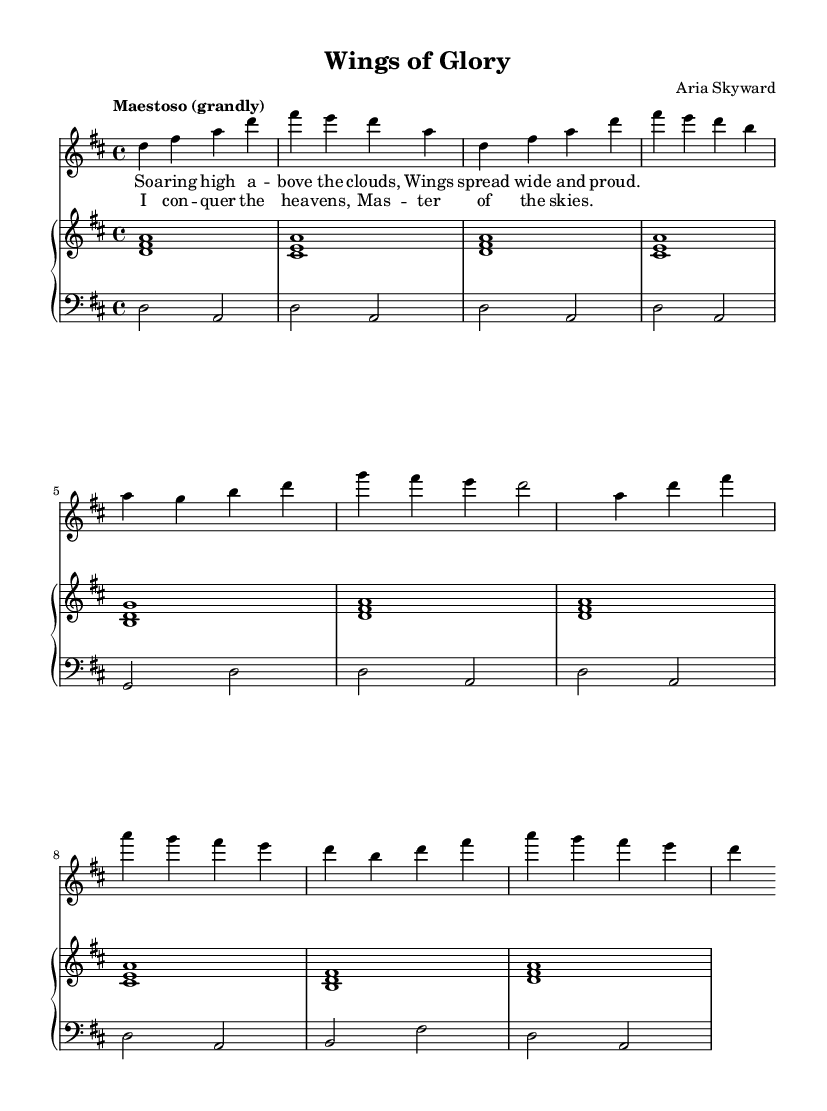What is the key signature of this music? The key signature is indicated at the beginning of the staff and shows two sharps, which corresponds to D major.
Answer: D major What is the time signature of this opera piece? The time signature is displayed next to the key signature at the beginning, indicating how many beats are in each measure. In this case, it shows 4 beats per measure.
Answer: 4/4 What is the tempo marking for this piece? The tempo marking is written above the music and indicates the speed of the piece. Here it is described as "Maestoso," which means it should be played grandly and stately.
Answer: Maestoso How many measures are there in the chorus section? By counting the measures within the chorus part of the sheet music, we can find that it contains four measures.
Answer: 4 Which voice part has the highest pitch range? By looking at the provided vocal lines, the soprano part, indicated at the top of the score, typically has the highest pitch range compared to the bass and piano parts.
Answer: Soprano What is the main theme expressed in the lyrics? The lyrics express themes of soaring above the clouds and conquering the heavens, indicating a connection to triumph and freedom in the sky.
Answer: Soaring high above the clouds How does the piano accompaniment contribute to the overall piece? The piano accompaniment provides harmonic support and emphasizes the structure of the opera, playing chords that complement the soprano's melodic line while also driving the rhythm forward.
Answer: Harmonic support 